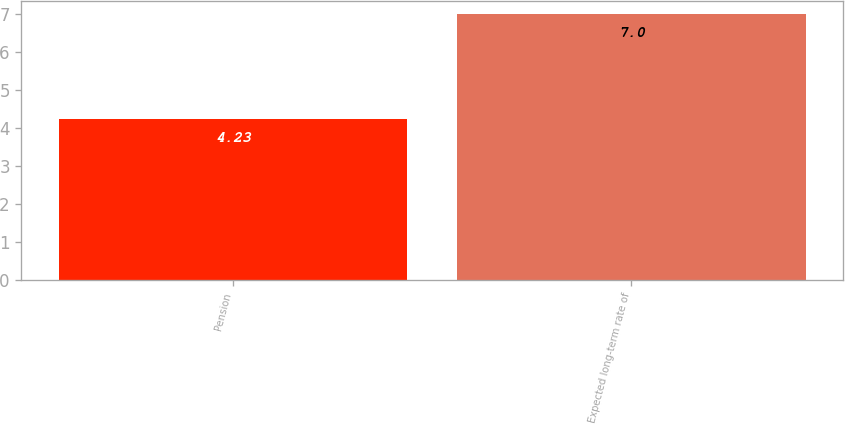Convert chart. <chart><loc_0><loc_0><loc_500><loc_500><bar_chart><fcel>Pension<fcel>Expected long-term rate of<nl><fcel>4.23<fcel>7<nl></chart> 